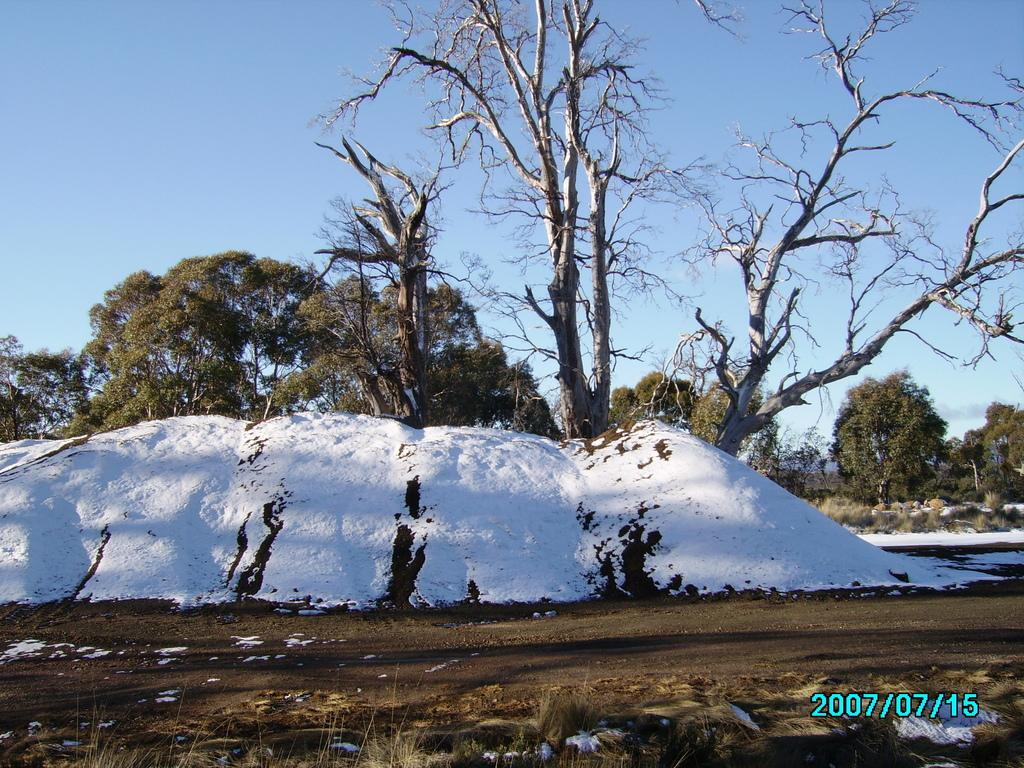What type of weather is depicted in the image? There is snow in the image, indicating a winter scene. What natural elements can be seen in the image? There are trees, plants, grass, and the sky visible in the image. Where is the watermark located in the image? The watermark is in the right side bottom corner of the image. What information does the watermark provide? The watermark represents a date. What type of song is being played in the hall in the image? There is no hall or song present in the image; it features a snowy scene with trees, plants, grass, and a sky visible in the background. What type of plastic object can be seen in the image? There is no plastic object present in the image. 